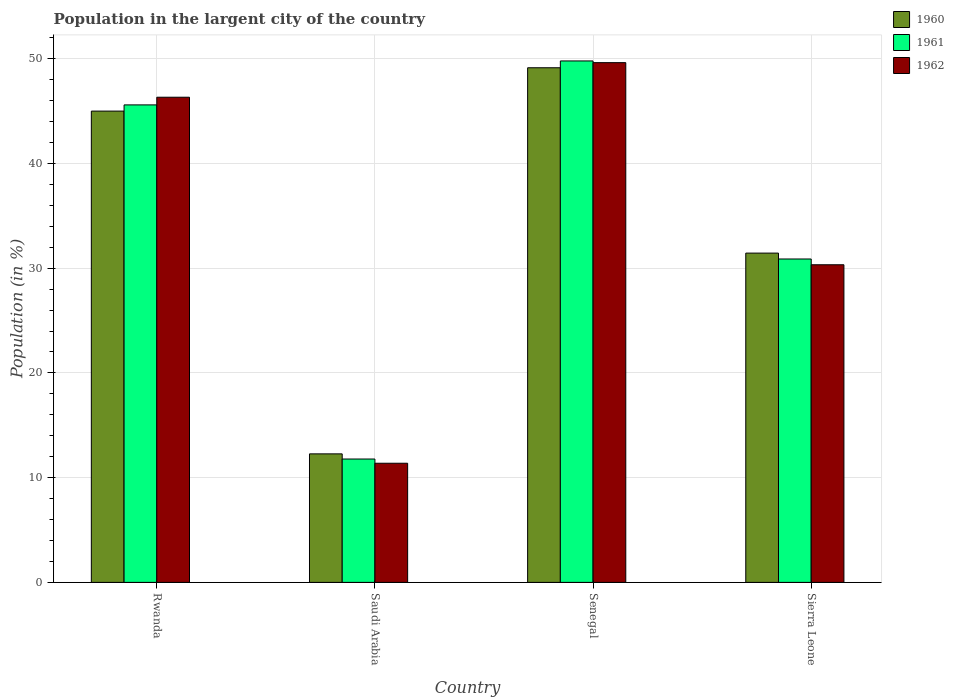How many different coloured bars are there?
Ensure brevity in your answer.  3. Are the number of bars per tick equal to the number of legend labels?
Provide a succinct answer. Yes. Are the number of bars on each tick of the X-axis equal?
Offer a very short reply. Yes. How many bars are there on the 3rd tick from the right?
Ensure brevity in your answer.  3. What is the label of the 1st group of bars from the left?
Keep it short and to the point. Rwanda. In how many cases, is the number of bars for a given country not equal to the number of legend labels?
Ensure brevity in your answer.  0. What is the percentage of population in the largent city in 1962 in Rwanda?
Keep it short and to the point. 46.32. Across all countries, what is the maximum percentage of population in the largent city in 1960?
Keep it short and to the point. 49.13. Across all countries, what is the minimum percentage of population in the largent city in 1961?
Offer a terse response. 11.78. In which country was the percentage of population in the largent city in 1961 maximum?
Give a very brief answer. Senegal. In which country was the percentage of population in the largent city in 1961 minimum?
Your answer should be compact. Saudi Arabia. What is the total percentage of population in the largent city in 1962 in the graph?
Your response must be concise. 137.65. What is the difference between the percentage of population in the largent city in 1960 in Senegal and that in Sierra Leone?
Your answer should be compact. 17.7. What is the difference between the percentage of population in the largent city in 1962 in Senegal and the percentage of population in the largent city in 1960 in Rwanda?
Ensure brevity in your answer.  4.63. What is the average percentage of population in the largent city in 1960 per country?
Your response must be concise. 34.46. What is the difference between the percentage of population in the largent city of/in 1960 and percentage of population in the largent city of/in 1962 in Senegal?
Give a very brief answer. -0.49. What is the ratio of the percentage of population in the largent city in 1960 in Saudi Arabia to that in Senegal?
Ensure brevity in your answer.  0.25. Is the percentage of population in the largent city in 1960 in Senegal less than that in Sierra Leone?
Keep it short and to the point. No. Is the difference between the percentage of population in the largent city in 1960 in Rwanda and Sierra Leone greater than the difference between the percentage of population in the largent city in 1962 in Rwanda and Sierra Leone?
Make the answer very short. No. What is the difference between the highest and the second highest percentage of population in the largent city in 1960?
Give a very brief answer. 4.14. What is the difference between the highest and the lowest percentage of population in the largent city in 1960?
Ensure brevity in your answer.  36.86. Is the sum of the percentage of population in the largent city in 1960 in Saudi Arabia and Sierra Leone greater than the maximum percentage of population in the largent city in 1961 across all countries?
Your response must be concise. No. What does the 1st bar from the left in Rwanda represents?
Offer a terse response. 1960. Are all the bars in the graph horizontal?
Your answer should be compact. No. How many countries are there in the graph?
Provide a succinct answer. 4. Are the values on the major ticks of Y-axis written in scientific E-notation?
Your answer should be compact. No. Does the graph contain grids?
Ensure brevity in your answer.  Yes. How many legend labels are there?
Provide a succinct answer. 3. How are the legend labels stacked?
Provide a succinct answer. Vertical. What is the title of the graph?
Keep it short and to the point. Population in the largent city of the country. Does "2005" appear as one of the legend labels in the graph?
Keep it short and to the point. No. What is the label or title of the Y-axis?
Make the answer very short. Population (in %). What is the Population (in %) of 1960 in Rwanda?
Your answer should be very brief. 45. What is the Population (in %) of 1961 in Rwanda?
Provide a short and direct response. 45.59. What is the Population (in %) of 1962 in Rwanda?
Your response must be concise. 46.32. What is the Population (in %) in 1960 in Saudi Arabia?
Keep it short and to the point. 12.27. What is the Population (in %) in 1961 in Saudi Arabia?
Provide a short and direct response. 11.78. What is the Population (in %) of 1962 in Saudi Arabia?
Provide a short and direct response. 11.38. What is the Population (in %) in 1960 in Senegal?
Your answer should be compact. 49.13. What is the Population (in %) of 1961 in Senegal?
Keep it short and to the point. 49.79. What is the Population (in %) of 1962 in Senegal?
Your answer should be compact. 49.62. What is the Population (in %) of 1960 in Sierra Leone?
Offer a terse response. 31.44. What is the Population (in %) in 1961 in Sierra Leone?
Provide a succinct answer. 30.88. What is the Population (in %) of 1962 in Sierra Leone?
Offer a very short reply. 30.33. Across all countries, what is the maximum Population (in %) of 1960?
Provide a succinct answer. 49.13. Across all countries, what is the maximum Population (in %) in 1961?
Your response must be concise. 49.79. Across all countries, what is the maximum Population (in %) in 1962?
Your response must be concise. 49.62. Across all countries, what is the minimum Population (in %) of 1960?
Keep it short and to the point. 12.27. Across all countries, what is the minimum Population (in %) of 1961?
Ensure brevity in your answer.  11.78. Across all countries, what is the minimum Population (in %) in 1962?
Your answer should be very brief. 11.38. What is the total Population (in %) in 1960 in the graph?
Keep it short and to the point. 137.84. What is the total Population (in %) in 1961 in the graph?
Keep it short and to the point. 138.03. What is the total Population (in %) of 1962 in the graph?
Give a very brief answer. 137.65. What is the difference between the Population (in %) in 1960 in Rwanda and that in Saudi Arabia?
Offer a terse response. 32.73. What is the difference between the Population (in %) of 1961 in Rwanda and that in Saudi Arabia?
Your response must be concise. 33.81. What is the difference between the Population (in %) of 1962 in Rwanda and that in Saudi Arabia?
Your response must be concise. 34.95. What is the difference between the Population (in %) in 1960 in Rwanda and that in Senegal?
Ensure brevity in your answer.  -4.14. What is the difference between the Population (in %) in 1961 in Rwanda and that in Senegal?
Offer a terse response. -4.2. What is the difference between the Population (in %) in 1962 in Rwanda and that in Senegal?
Ensure brevity in your answer.  -3.3. What is the difference between the Population (in %) in 1960 in Rwanda and that in Sierra Leone?
Give a very brief answer. 13.56. What is the difference between the Population (in %) of 1961 in Rwanda and that in Sierra Leone?
Ensure brevity in your answer.  14.71. What is the difference between the Population (in %) of 1962 in Rwanda and that in Sierra Leone?
Provide a short and direct response. 16. What is the difference between the Population (in %) of 1960 in Saudi Arabia and that in Senegal?
Your answer should be compact. -36.86. What is the difference between the Population (in %) in 1961 in Saudi Arabia and that in Senegal?
Offer a very short reply. -38.01. What is the difference between the Population (in %) of 1962 in Saudi Arabia and that in Senegal?
Your response must be concise. -38.25. What is the difference between the Population (in %) of 1960 in Saudi Arabia and that in Sierra Leone?
Your answer should be compact. -19.17. What is the difference between the Population (in %) in 1961 in Saudi Arabia and that in Sierra Leone?
Your answer should be compact. -19.1. What is the difference between the Population (in %) of 1962 in Saudi Arabia and that in Sierra Leone?
Provide a succinct answer. -18.95. What is the difference between the Population (in %) in 1960 in Senegal and that in Sierra Leone?
Make the answer very short. 17.7. What is the difference between the Population (in %) in 1961 in Senegal and that in Sierra Leone?
Your answer should be compact. 18.91. What is the difference between the Population (in %) of 1962 in Senegal and that in Sierra Leone?
Make the answer very short. 19.3. What is the difference between the Population (in %) in 1960 in Rwanda and the Population (in %) in 1961 in Saudi Arabia?
Keep it short and to the point. 33.22. What is the difference between the Population (in %) of 1960 in Rwanda and the Population (in %) of 1962 in Saudi Arabia?
Make the answer very short. 33.62. What is the difference between the Population (in %) in 1961 in Rwanda and the Population (in %) in 1962 in Saudi Arabia?
Offer a very short reply. 34.21. What is the difference between the Population (in %) of 1960 in Rwanda and the Population (in %) of 1961 in Senegal?
Ensure brevity in your answer.  -4.79. What is the difference between the Population (in %) in 1960 in Rwanda and the Population (in %) in 1962 in Senegal?
Keep it short and to the point. -4.63. What is the difference between the Population (in %) of 1961 in Rwanda and the Population (in %) of 1962 in Senegal?
Your answer should be compact. -4.03. What is the difference between the Population (in %) of 1960 in Rwanda and the Population (in %) of 1961 in Sierra Leone?
Your answer should be very brief. 14.12. What is the difference between the Population (in %) of 1960 in Rwanda and the Population (in %) of 1962 in Sierra Leone?
Your response must be concise. 14.67. What is the difference between the Population (in %) in 1961 in Rwanda and the Population (in %) in 1962 in Sierra Leone?
Your answer should be very brief. 15.26. What is the difference between the Population (in %) in 1960 in Saudi Arabia and the Population (in %) in 1961 in Senegal?
Keep it short and to the point. -37.52. What is the difference between the Population (in %) in 1960 in Saudi Arabia and the Population (in %) in 1962 in Senegal?
Provide a succinct answer. -37.35. What is the difference between the Population (in %) of 1961 in Saudi Arabia and the Population (in %) of 1962 in Senegal?
Offer a terse response. -37.85. What is the difference between the Population (in %) of 1960 in Saudi Arabia and the Population (in %) of 1961 in Sierra Leone?
Your answer should be compact. -18.61. What is the difference between the Population (in %) in 1960 in Saudi Arabia and the Population (in %) in 1962 in Sierra Leone?
Offer a terse response. -18.06. What is the difference between the Population (in %) in 1961 in Saudi Arabia and the Population (in %) in 1962 in Sierra Leone?
Your answer should be very brief. -18.55. What is the difference between the Population (in %) in 1960 in Senegal and the Population (in %) in 1961 in Sierra Leone?
Offer a very short reply. 18.26. What is the difference between the Population (in %) in 1960 in Senegal and the Population (in %) in 1962 in Sierra Leone?
Give a very brief answer. 18.81. What is the difference between the Population (in %) of 1961 in Senegal and the Population (in %) of 1962 in Sierra Leone?
Your answer should be compact. 19.46. What is the average Population (in %) of 1960 per country?
Your response must be concise. 34.46. What is the average Population (in %) in 1961 per country?
Give a very brief answer. 34.51. What is the average Population (in %) in 1962 per country?
Your response must be concise. 34.41. What is the difference between the Population (in %) of 1960 and Population (in %) of 1961 in Rwanda?
Provide a succinct answer. -0.59. What is the difference between the Population (in %) of 1960 and Population (in %) of 1962 in Rwanda?
Your response must be concise. -1.32. What is the difference between the Population (in %) of 1961 and Population (in %) of 1962 in Rwanda?
Give a very brief answer. -0.73. What is the difference between the Population (in %) in 1960 and Population (in %) in 1961 in Saudi Arabia?
Your answer should be compact. 0.49. What is the difference between the Population (in %) of 1960 and Population (in %) of 1962 in Saudi Arabia?
Give a very brief answer. 0.89. What is the difference between the Population (in %) of 1961 and Population (in %) of 1962 in Saudi Arabia?
Give a very brief answer. 0.4. What is the difference between the Population (in %) of 1960 and Population (in %) of 1961 in Senegal?
Keep it short and to the point. -0.65. What is the difference between the Population (in %) in 1960 and Population (in %) in 1962 in Senegal?
Your answer should be compact. -0.49. What is the difference between the Population (in %) in 1961 and Population (in %) in 1962 in Senegal?
Give a very brief answer. 0.16. What is the difference between the Population (in %) in 1960 and Population (in %) in 1961 in Sierra Leone?
Your response must be concise. 0.56. What is the difference between the Population (in %) of 1960 and Population (in %) of 1962 in Sierra Leone?
Provide a succinct answer. 1.11. What is the difference between the Population (in %) in 1961 and Population (in %) in 1962 in Sierra Leone?
Your response must be concise. 0.55. What is the ratio of the Population (in %) in 1960 in Rwanda to that in Saudi Arabia?
Give a very brief answer. 3.67. What is the ratio of the Population (in %) in 1961 in Rwanda to that in Saudi Arabia?
Your answer should be very brief. 3.87. What is the ratio of the Population (in %) of 1962 in Rwanda to that in Saudi Arabia?
Your answer should be very brief. 4.07. What is the ratio of the Population (in %) in 1960 in Rwanda to that in Senegal?
Your answer should be very brief. 0.92. What is the ratio of the Population (in %) of 1961 in Rwanda to that in Senegal?
Provide a succinct answer. 0.92. What is the ratio of the Population (in %) in 1962 in Rwanda to that in Senegal?
Your response must be concise. 0.93. What is the ratio of the Population (in %) of 1960 in Rwanda to that in Sierra Leone?
Provide a short and direct response. 1.43. What is the ratio of the Population (in %) in 1961 in Rwanda to that in Sierra Leone?
Keep it short and to the point. 1.48. What is the ratio of the Population (in %) in 1962 in Rwanda to that in Sierra Leone?
Give a very brief answer. 1.53. What is the ratio of the Population (in %) of 1960 in Saudi Arabia to that in Senegal?
Provide a short and direct response. 0.25. What is the ratio of the Population (in %) of 1961 in Saudi Arabia to that in Senegal?
Keep it short and to the point. 0.24. What is the ratio of the Population (in %) in 1962 in Saudi Arabia to that in Senegal?
Provide a short and direct response. 0.23. What is the ratio of the Population (in %) in 1960 in Saudi Arabia to that in Sierra Leone?
Ensure brevity in your answer.  0.39. What is the ratio of the Population (in %) of 1961 in Saudi Arabia to that in Sierra Leone?
Your answer should be very brief. 0.38. What is the ratio of the Population (in %) in 1962 in Saudi Arabia to that in Sierra Leone?
Offer a very short reply. 0.38. What is the ratio of the Population (in %) in 1960 in Senegal to that in Sierra Leone?
Make the answer very short. 1.56. What is the ratio of the Population (in %) of 1961 in Senegal to that in Sierra Leone?
Provide a short and direct response. 1.61. What is the ratio of the Population (in %) in 1962 in Senegal to that in Sierra Leone?
Your answer should be very brief. 1.64. What is the difference between the highest and the second highest Population (in %) in 1960?
Provide a succinct answer. 4.14. What is the difference between the highest and the second highest Population (in %) in 1961?
Provide a short and direct response. 4.2. What is the difference between the highest and the second highest Population (in %) of 1962?
Keep it short and to the point. 3.3. What is the difference between the highest and the lowest Population (in %) in 1960?
Your answer should be compact. 36.86. What is the difference between the highest and the lowest Population (in %) in 1961?
Offer a terse response. 38.01. What is the difference between the highest and the lowest Population (in %) of 1962?
Ensure brevity in your answer.  38.25. 